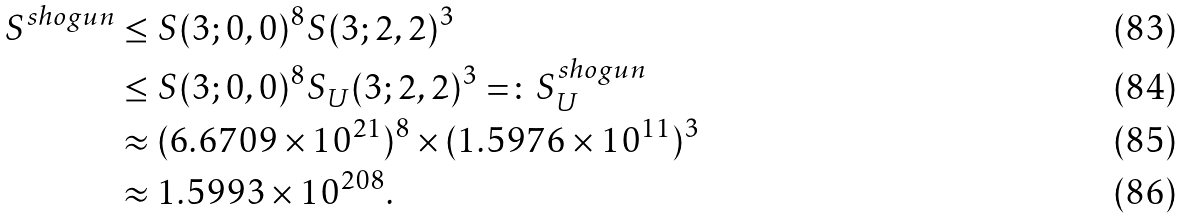<formula> <loc_0><loc_0><loc_500><loc_500>S ^ { s h o g u n } & \leq S ( 3 ; 0 , 0 ) ^ { 8 } S ( 3 ; 2 , 2 ) ^ { 3 } \\ & \leq S ( 3 ; 0 , 0 ) ^ { 8 } S _ { U } ( 3 ; 2 , 2 ) ^ { 3 } = \colon S _ { U } ^ { s h o g u n } \\ & \approx ( 6 . 6 7 0 9 \times 1 0 ^ { 2 1 } ) ^ { 8 } \times ( 1 . 5 9 7 6 \times 1 0 ^ { 1 1 } ) ^ { 3 } \\ & \approx 1 . 5 9 9 3 \times 1 0 ^ { 2 0 8 } .</formula> 